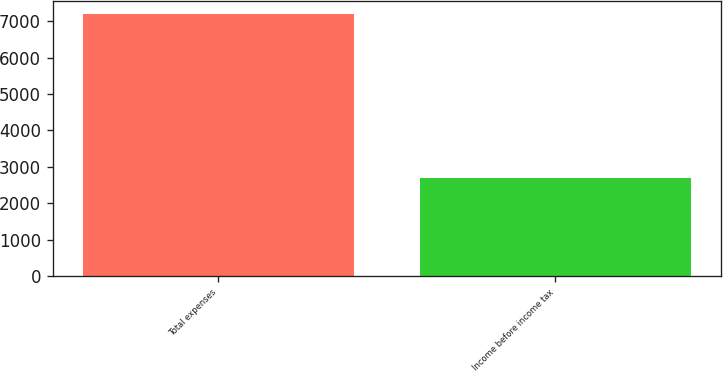Convert chart. <chart><loc_0><loc_0><loc_500><loc_500><bar_chart><fcel>Total expenses<fcel>Income before income tax<nl><fcel>7192<fcel>2686<nl></chart> 